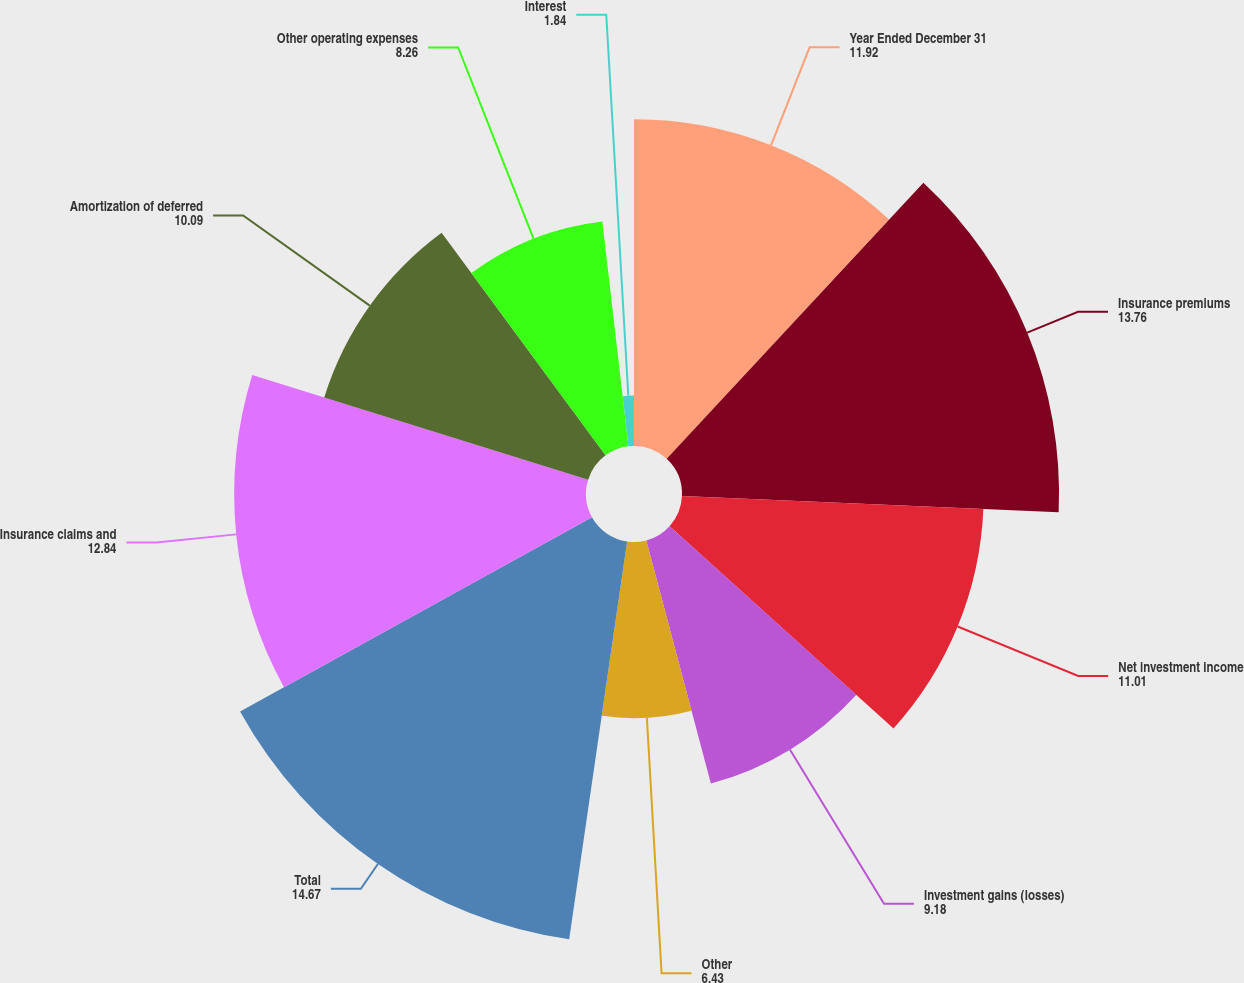Convert chart. <chart><loc_0><loc_0><loc_500><loc_500><pie_chart><fcel>Year Ended December 31<fcel>Insurance premiums<fcel>Net investment income<fcel>Investment gains (losses)<fcel>Other<fcel>Total<fcel>Insurance claims and<fcel>Amortization of deferred<fcel>Other operating expenses<fcel>Interest<nl><fcel>11.92%<fcel>13.76%<fcel>11.01%<fcel>9.18%<fcel>6.43%<fcel>14.67%<fcel>12.84%<fcel>10.09%<fcel>8.26%<fcel>1.84%<nl></chart> 